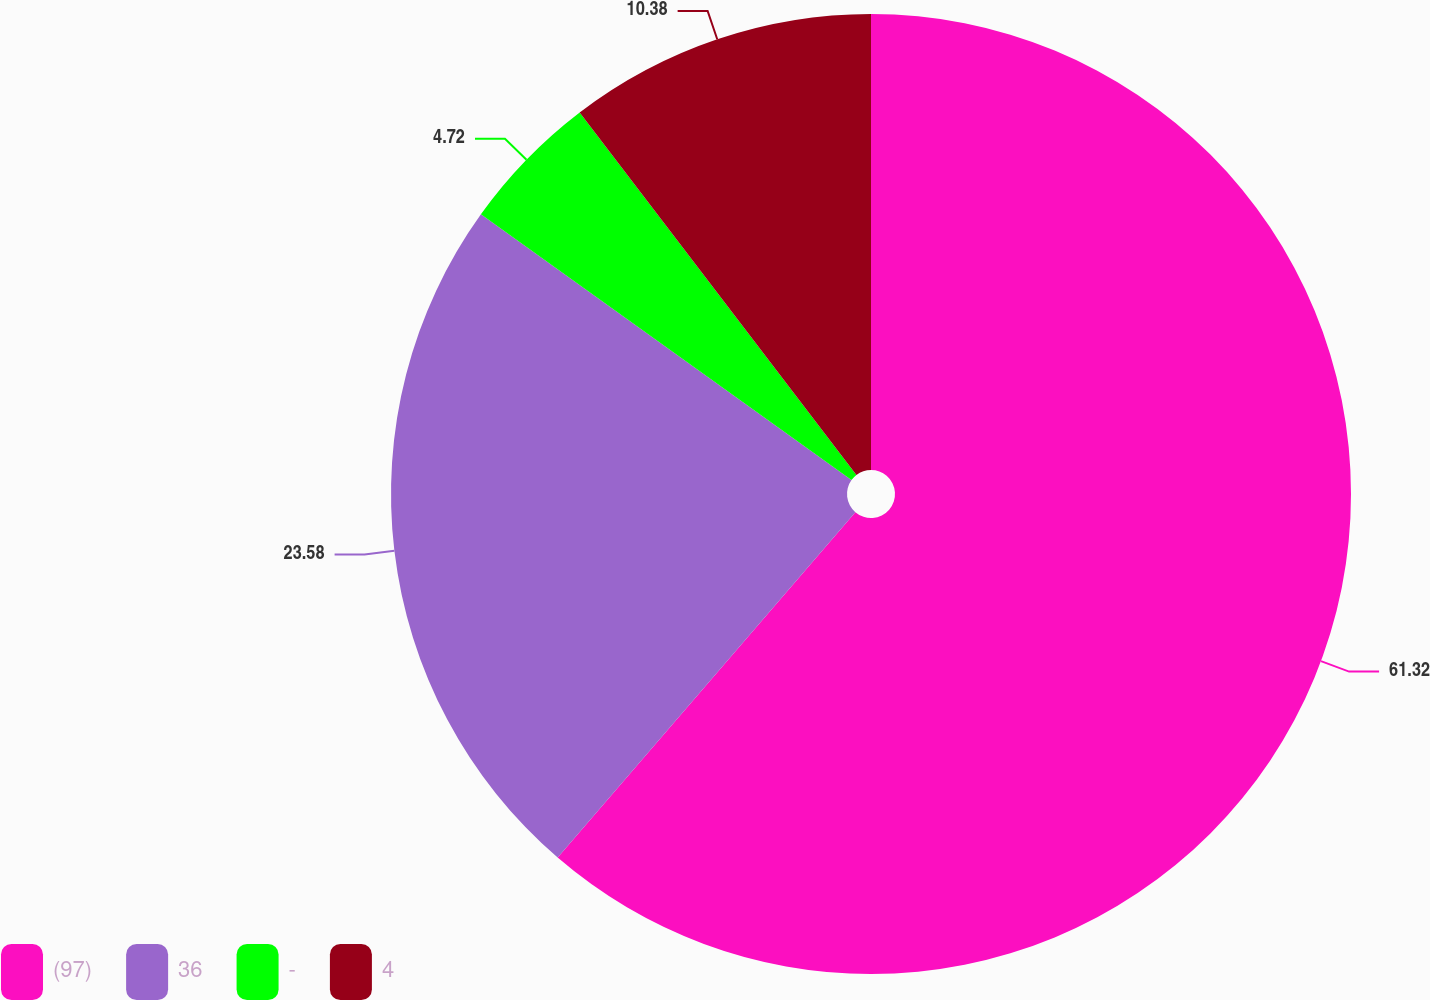Convert chart to OTSL. <chart><loc_0><loc_0><loc_500><loc_500><pie_chart><fcel>(97)<fcel>36<fcel>-<fcel>4<nl><fcel>61.32%<fcel>23.58%<fcel>4.72%<fcel>10.38%<nl></chart> 